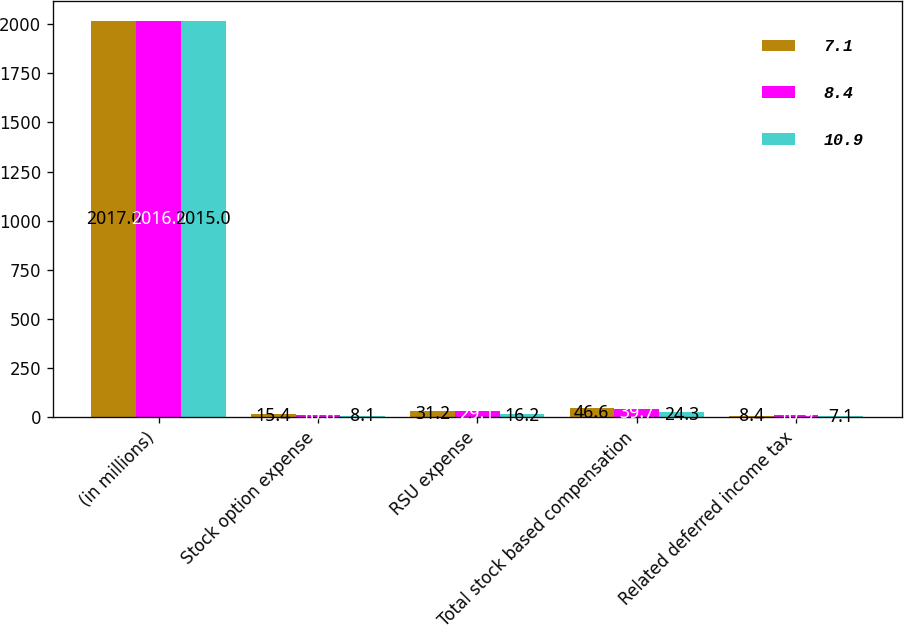<chart> <loc_0><loc_0><loc_500><loc_500><stacked_bar_chart><ecel><fcel>(in millions)<fcel>Stock option expense<fcel>RSU expense<fcel>Total stock based compensation<fcel>Related deferred income tax<nl><fcel>7.1<fcel>2017<fcel>15.4<fcel>31.2<fcel>46.6<fcel>8.4<nl><fcel>8.4<fcel>2016<fcel>10.6<fcel>29.1<fcel>39.7<fcel>10.9<nl><fcel>10.9<fcel>2015<fcel>8.1<fcel>16.2<fcel>24.3<fcel>7.1<nl></chart> 